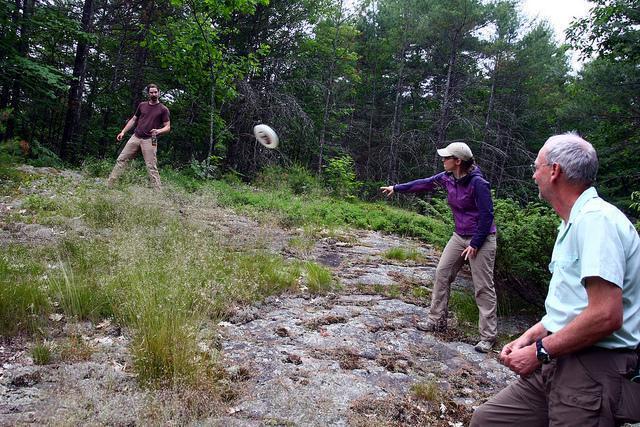Who is standing at a higher level on the rock?
Choose the correct response, then elucidate: 'Answer: answer
Rationale: rationale.'
Options: Blue shirt, brown shirt, purple shirt, white frisbee. Answer: brown shirt.
Rationale: The brown shirt is higher. 